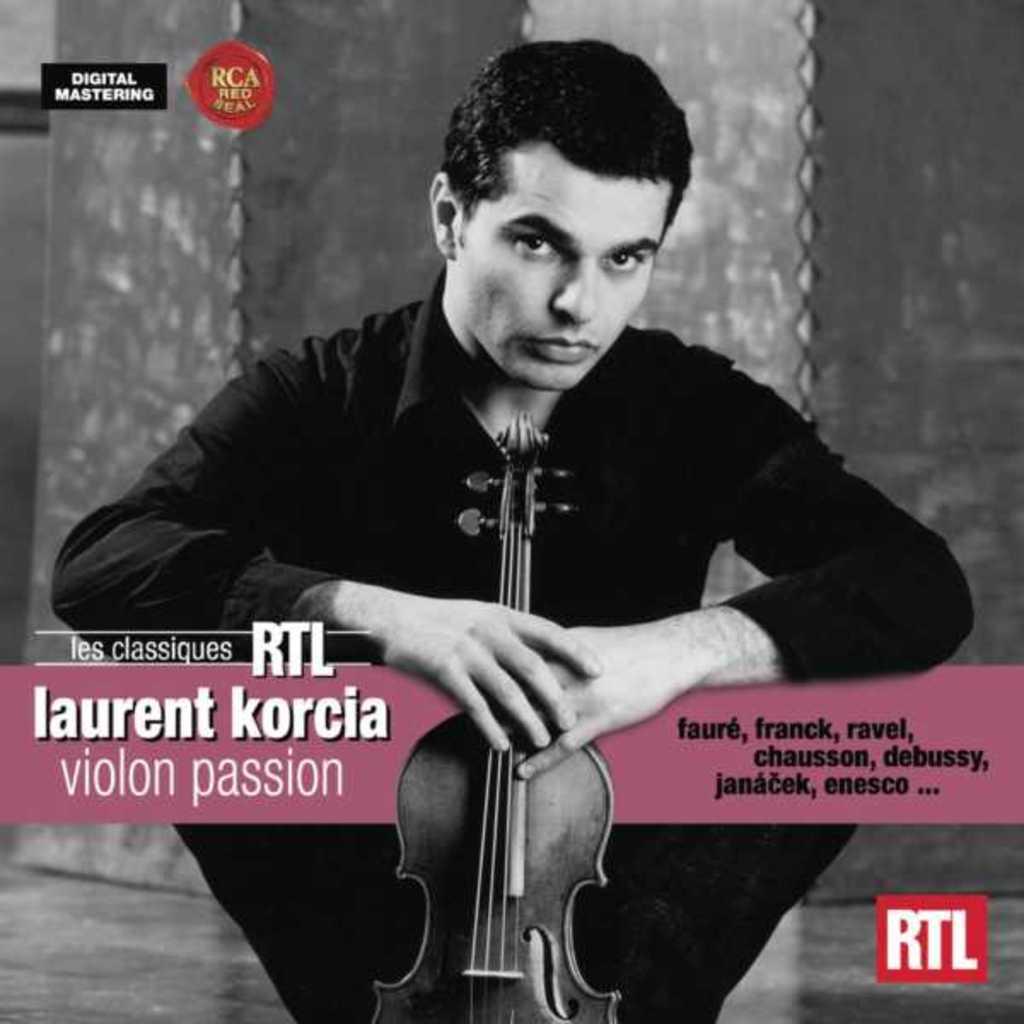Please provide a concise description of this image. A black and white picture. This man is sitting on a floor and holding a guitar. 